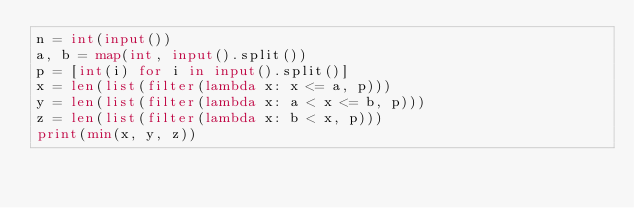<code> <loc_0><loc_0><loc_500><loc_500><_Python_>n = int(input())
a, b = map(int, input().split())
p = [int(i) for i in input().split()]
x = len(list(filter(lambda x: x <= a, p)))
y = len(list(filter(lambda x: a < x <= b, p)))
z = len(list(filter(lambda x: b < x, p)))
print(min(x, y, z))
</code> 